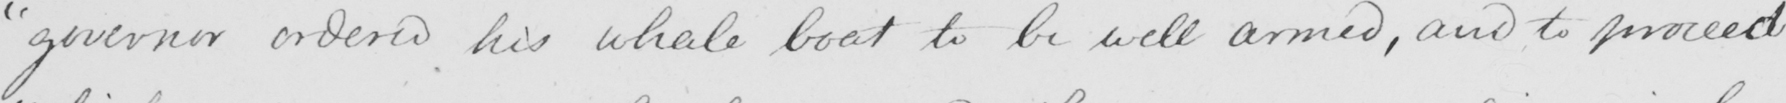What is written in this line of handwriting? " governor ordered his whale boat to be well armed , and to proceed 